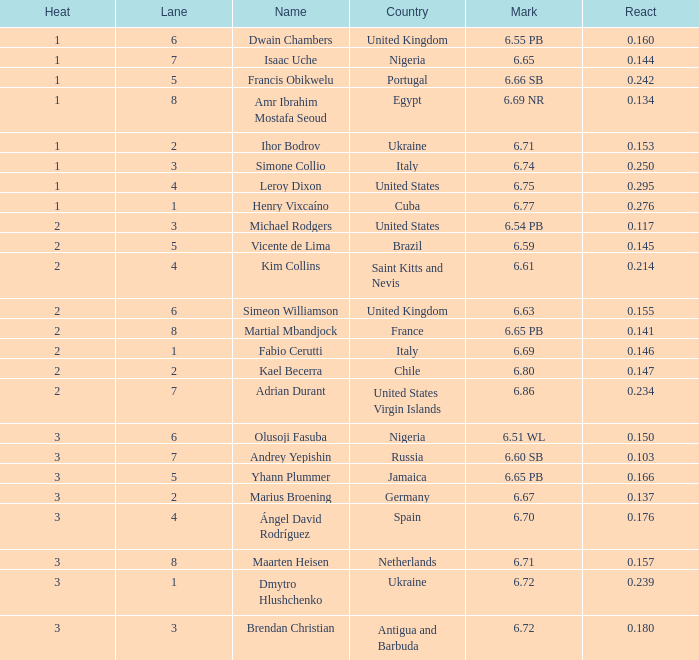14100000000000001? 8.0. 